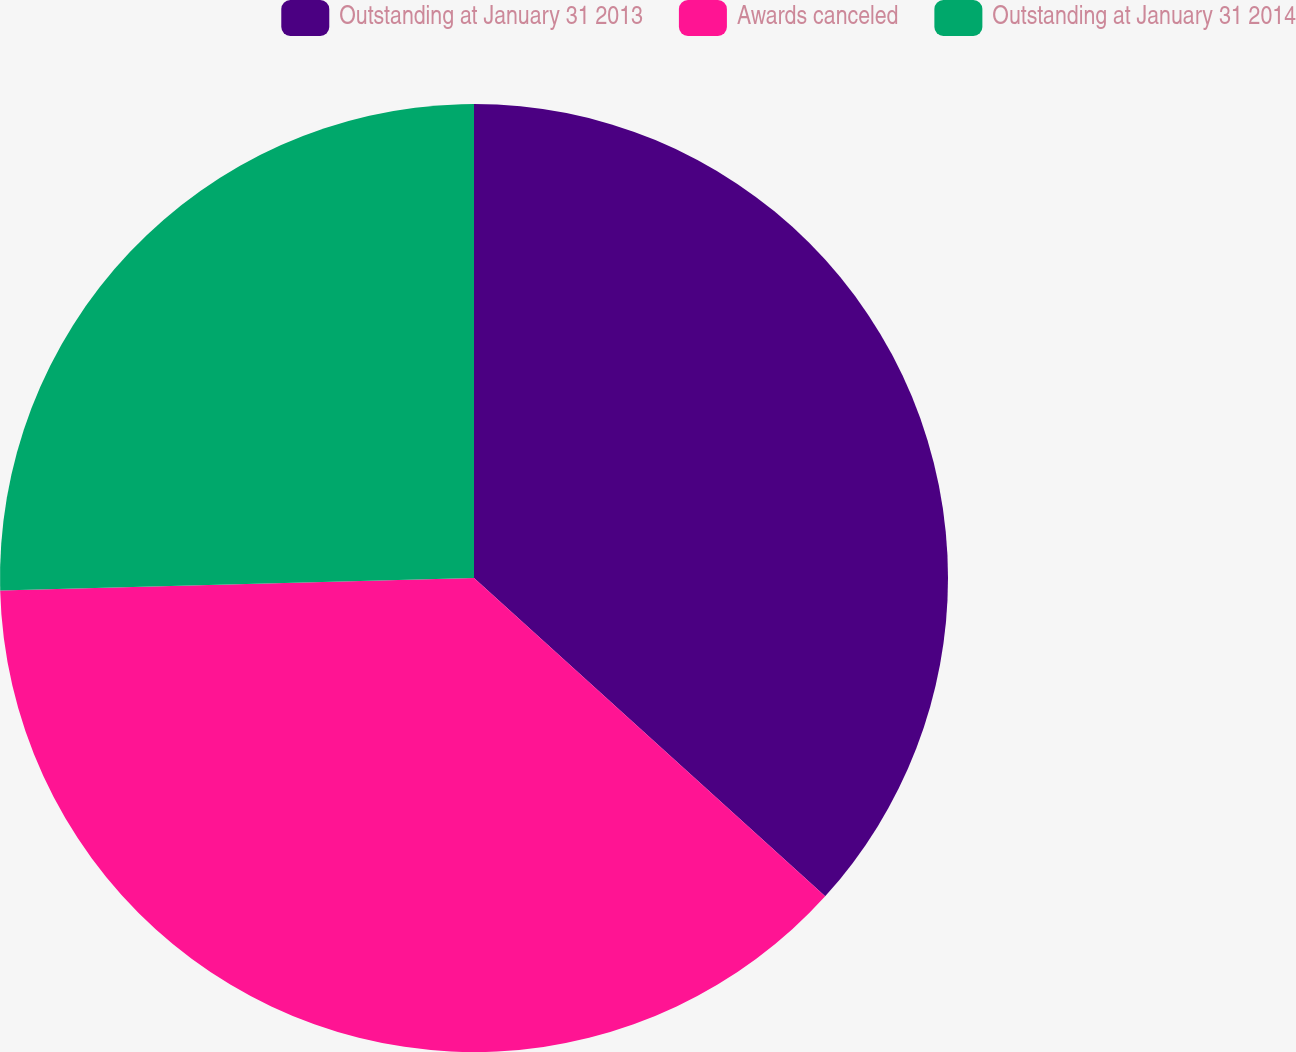Convert chart to OTSL. <chart><loc_0><loc_0><loc_500><loc_500><pie_chart><fcel>Outstanding at January 31 2013<fcel>Awards canceled<fcel>Outstanding at January 31 2014<nl><fcel>36.72%<fcel>37.86%<fcel>25.42%<nl></chart> 